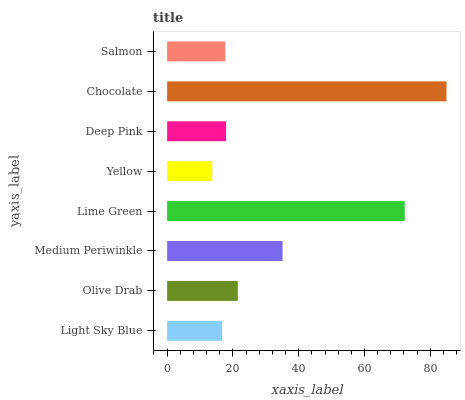Is Yellow the minimum?
Answer yes or no. Yes. Is Chocolate the maximum?
Answer yes or no. Yes. Is Olive Drab the minimum?
Answer yes or no. No. Is Olive Drab the maximum?
Answer yes or no. No. Is Olive Drab greater than Light Sky Blue?
Answer yes or no. Yes. Is Light Sky Blue less than Olive Drab?
Answer yes or no. Yes. Is Light Sky Blue greater than Olive Drab?
Answer yes or no. No. Is Olive Drab less than Light Sky Blue?
Answer yes or no. No. Is Olive Drab the high median?
Answer yes or no. Yes. Is Deep Pink the low median?
Answer yes or no. Yes. Is Light Sky Blue the high median?
Answer yes or no. No. Is Yellow the low median?
Answer yes or no. No. 